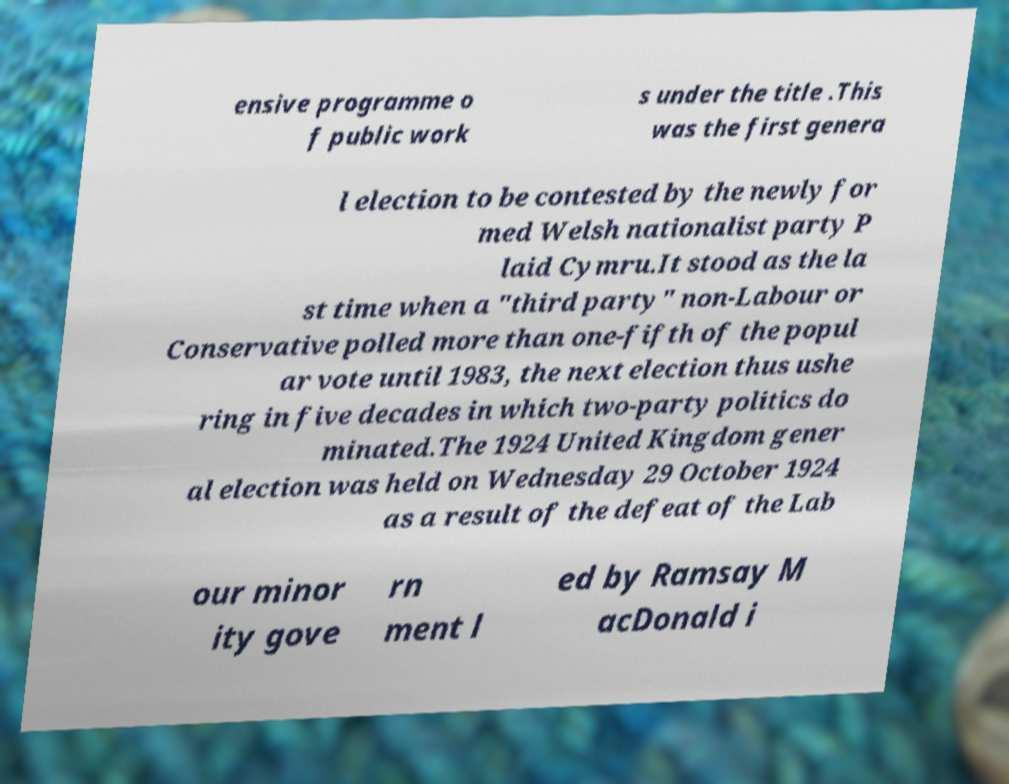There's text embedded in this image that I need extracted. Can you transcribe it verbatim? ensive programme o f public work s under the title .This was the first genera l election to be contested by the newly for med Welsh nationalist party P laid Cymru.It stood as the la st time when a "third party" non-Labour or Conservative polled more than one-fifth of the popul ar vote until 1983, the next election thus ushe ring in five decades in which two-party politics do minated.The 1924 United Kingdom gener al election was held on Wednesday 29 October 1924 as a result of the defeat of the Lab our minor ity gove rn ment l ed by Ramsay M acDonald i 